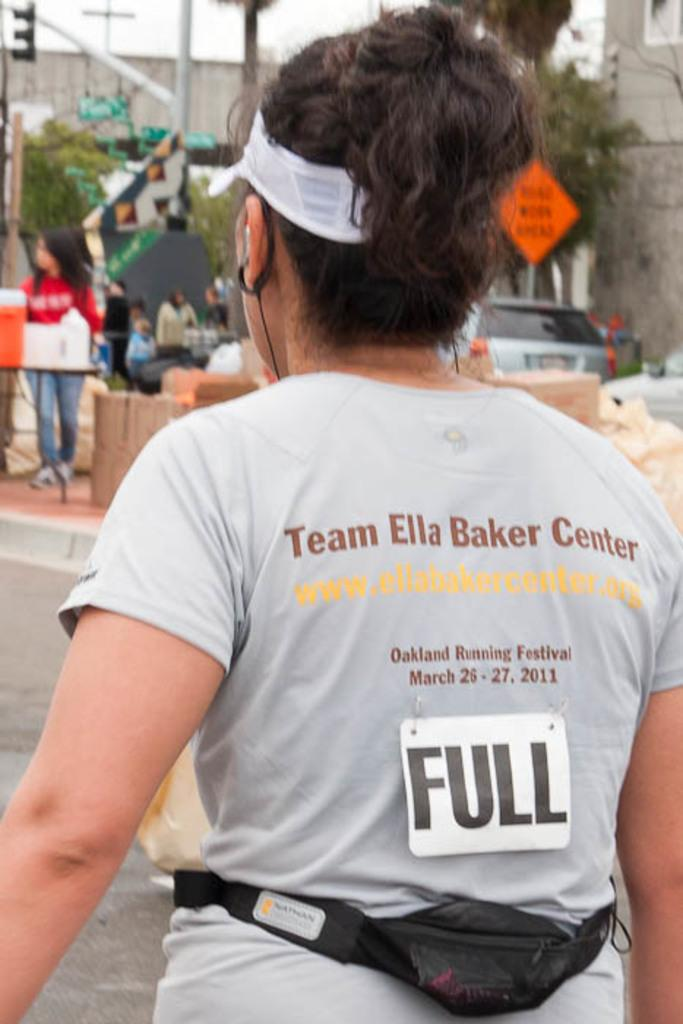Provide a one-sentence caption for the provided image. People are taking part in the Oakland Running Festival. 